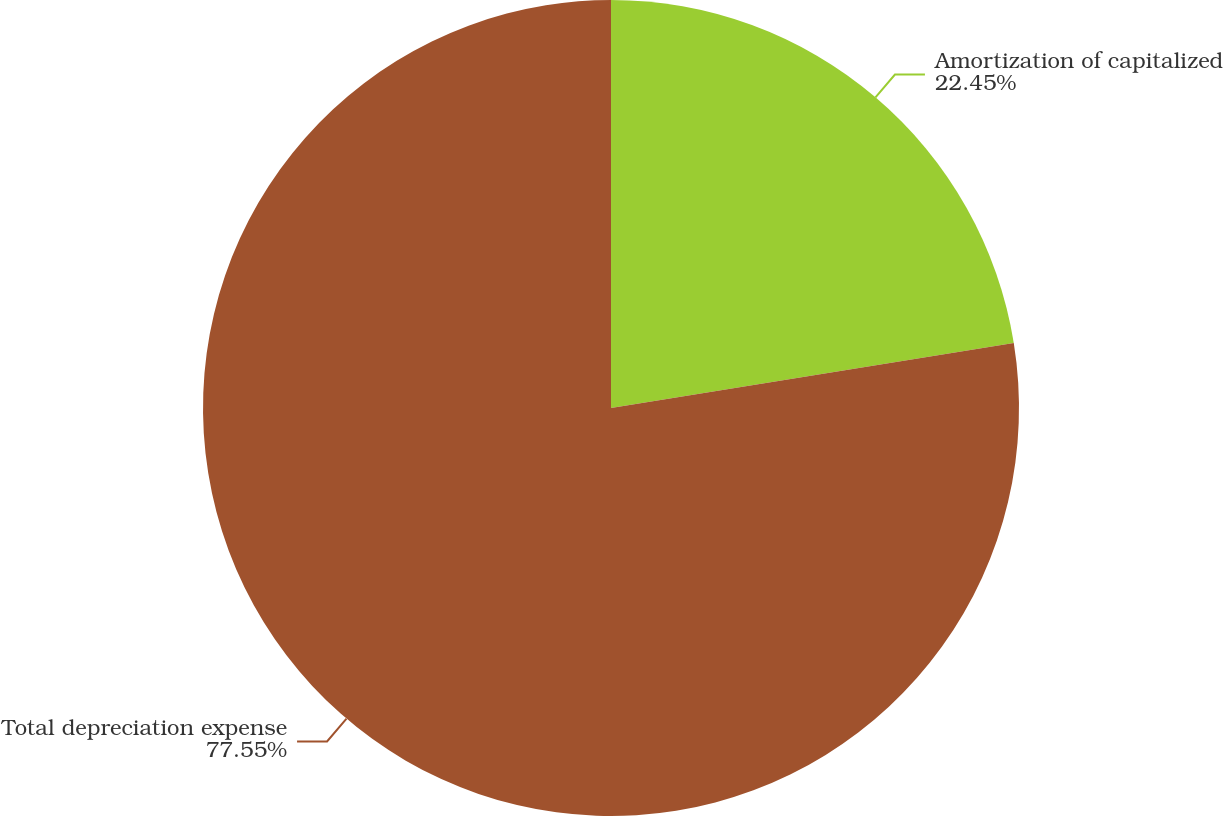<chart> <loc_0><loc_0><loc_500><loc_500><pie_chart><fcel>Amortization of capitalized<fcel>Total depreciation expense<nl><fcel>22.45%<fcel>77.55%<nl></chart> 